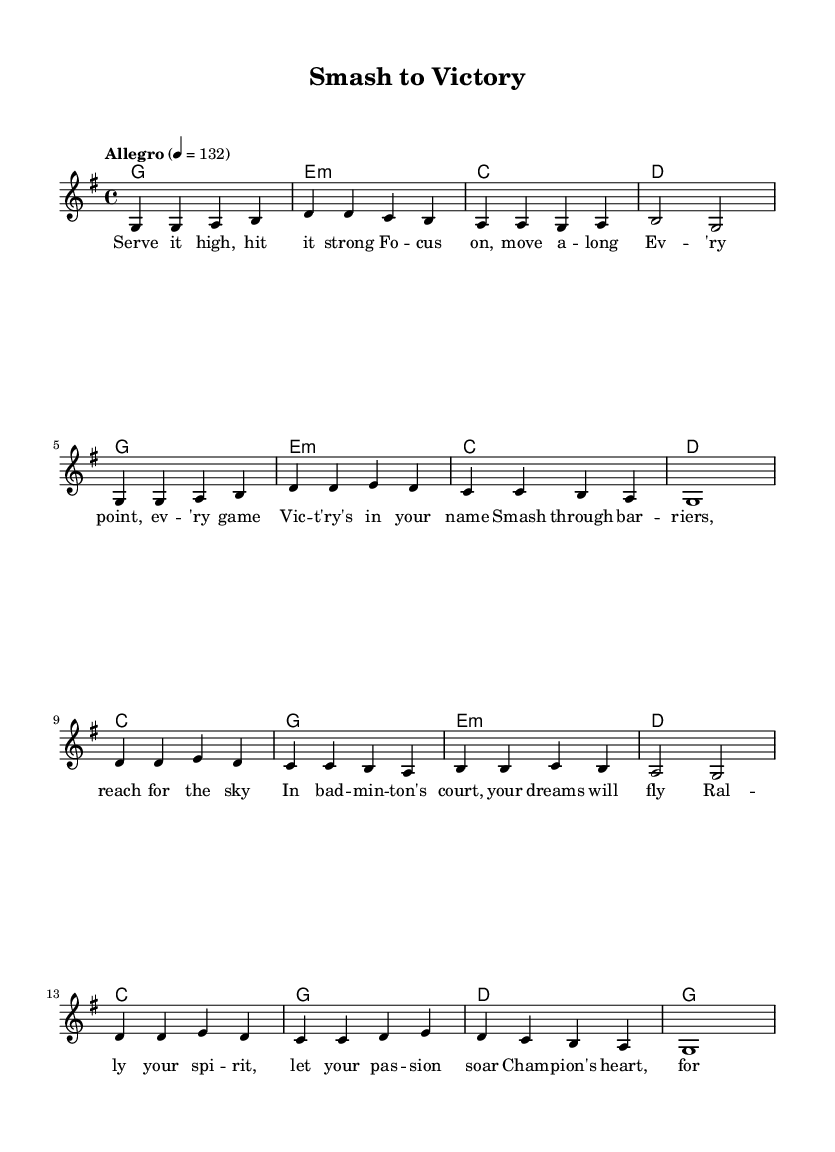What is the key signature of this music? The key signature is G major, which has one sharp (F#). We can determine this from the global section of the code, where it states "\key g \major."
Answer: G major What is the time signature of the piece? The time signature is 4/4, explicitly mentioned in the global section as "\time 4/4." This means there are four beats per measure.
Answer: 4/4 What is the tempo marking of the piece? The tempo marking given in the score is "Allegro," with a metronome mark of 132 beats per minute. This indicates a fast tempo, characteristic of upbeat music.
Answer: Allegro How many measures does the melody consist of? The melody is structured in a way that has a total of 16 measures. This can be counted from the melody section where it is divided into segments for clarity.
Answer: 16 What is the theme of the lyrics? The lyrics convey a motivational message about overcoming challenges in badminton and achieving victory. Key phrases reflect determination, such as "Smash through barriers" and "champion's heart."
Answer: Overcoming challenges How many different chords are used in the harmonies? There are four unique chords used in the harmonies: G major, E minor, C major, and D major. This can be identified by listing out the chords in the harmony section of the code.
Answer: Four What is the structure of the song based on the lyrics? The song follows a standard structure that includes verses and a chorus. The verses introduce the theme, while the chorus provides a climactic expression of the song's core message about striving for success.
Answer: Verse and chorus 